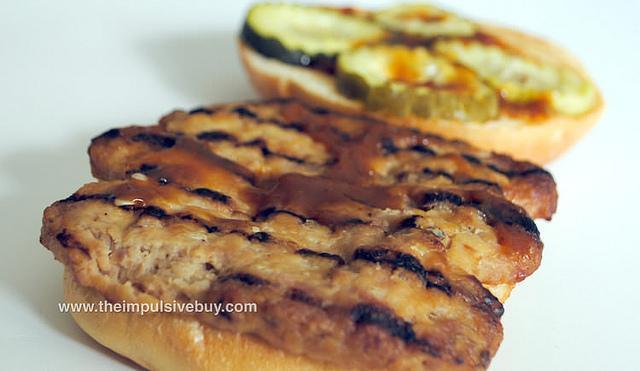How many pickles are on the bun?
Give a very brief answer. 4. How many sandwiches are there?
Give a very brief answer. 4. How many sinks are in the picture?
Give a very brief answer. 0. 